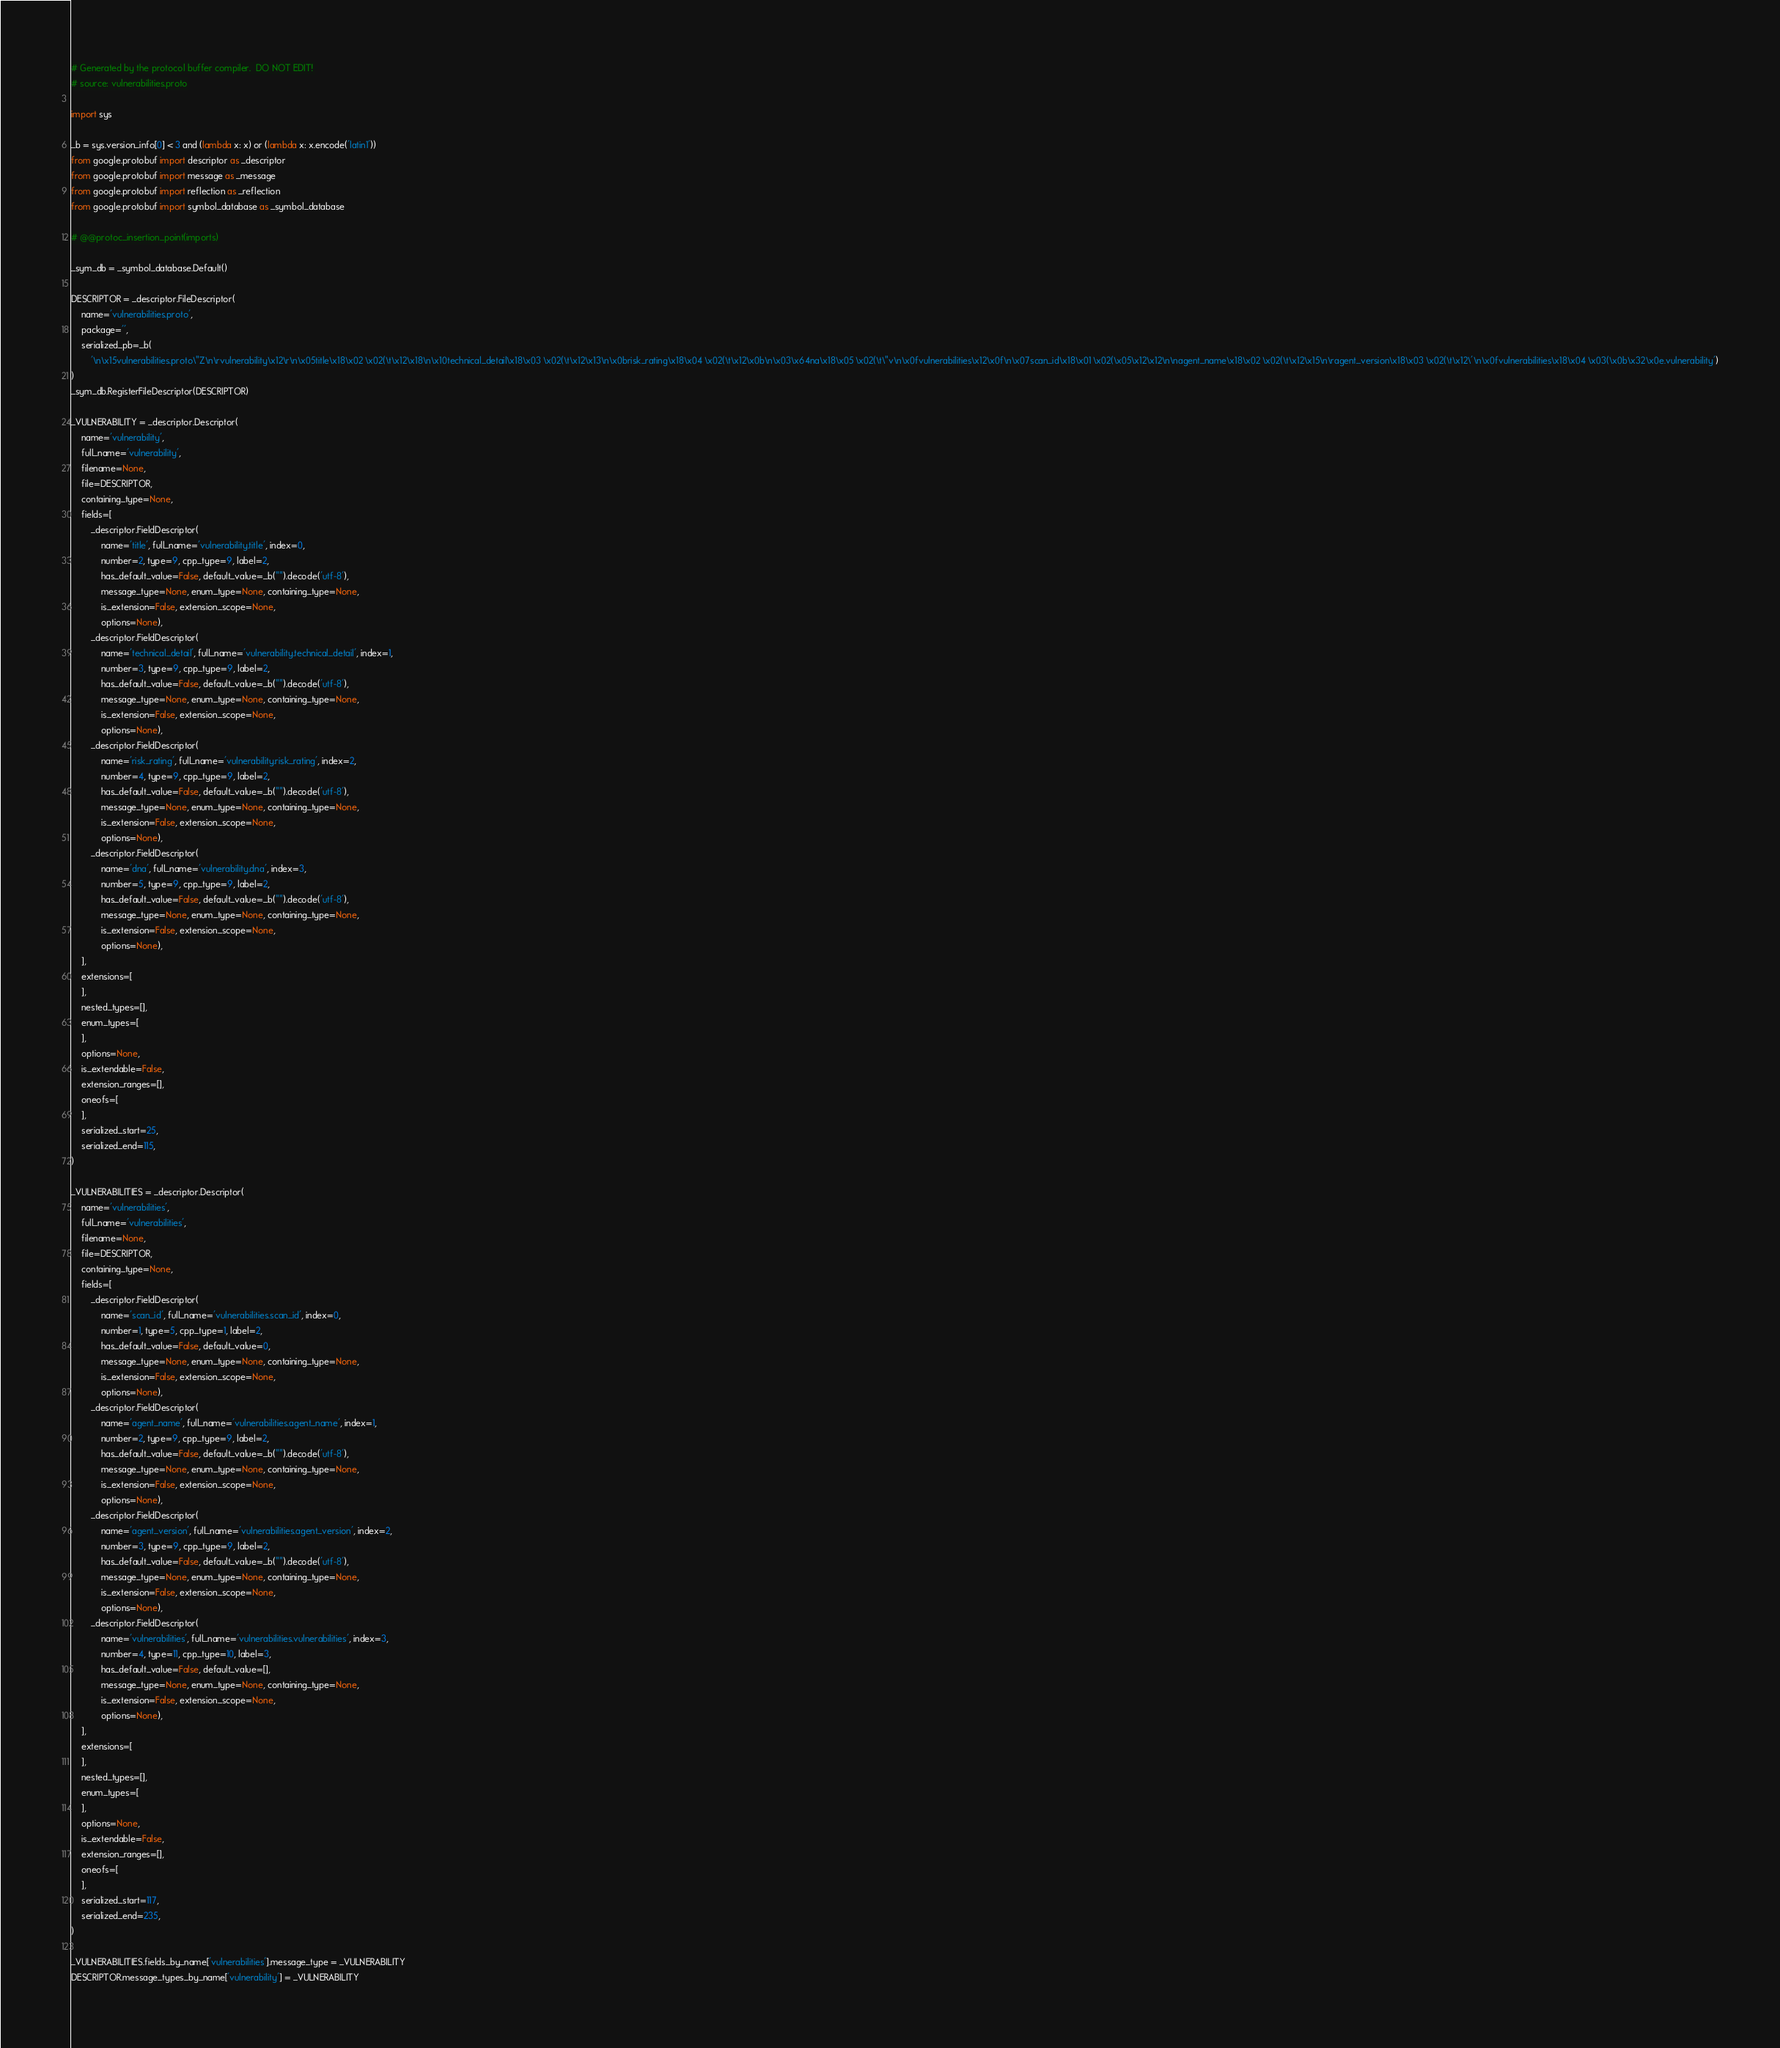<code> <loc_0><loc_0><loc_500><loc_500><_Python_># Generated by the protocol buffer compiler.  DO NOT EDIT!
# source: vulnerabilities.proto

import sys

_b = sys.version_info[0] < 3 and (lambda x: x) or (lambda x: x.encode('latin1'))
from google.protobuf import descriptor as _descriptor
from google.protobuf import message as _message
from google.protobuf import reflection as _reflection
from google.protobuf import symbol_database as _symbol_database

# @@protoc_insertion_point(imports)

_sym_db = _symbol_database.Default()

DESCRIPTOR = _descriptor.FileDescriptor(
    name='vulnerabilities.proto',
    package='',
    serialized_pb=_b(
        '\n\x15vulnerabilities.proto\"Z\n\rvulnerability\x12\r\n\x05title\x18\x02 \x02(\t\x12\x18\n\x10technical_detail\x18\x03 \x02(\t\x12\x13\n\x0brisk_rating\x18\x04 \x02(\t\x12\x0b\n\x03\x64na\x18\x05 \x02(\t\"v\n\x0fvulnerabilities\x12\x0f\n\x07scan_id\x18\x01 \x02(\x05\x12\x12\n\nagent_name\x18\x02 \x02(\t\x12\x15\n\ragent_version\x18\x03 \x02(\t\x12\'\n\x0fvulnerabilities\x18\x04 \x03(\x0b\x32\x0e.vulnerability')
)
_sym_db.RegisterFileDescriptor(DESCRIPTOR)

_VULNERABILITY = _descriptor.Descriptor(
    name='vulnerability',
    full_name='vulnerability',
    filename=None,
    file=DESCRIPTOR,
    containing_type=None,
    fields=[
        _descriptor.FieldDescriptor(
            name='title', full_name='vulnerability.title', index=0,
            number=2, type=9, cpp_type=9, label=2,
            has_default_value=False, default_value=_b("").decode('utf-8'),
            message_type=None, enum_type=None, containing_type=None,
            is_extension=False, extension_scope=None,
            options=None),
        _descriptor.FieldDescriptor(
            name='technical_detail', full_name='vulnerability.technical_detail', index=1,
            number=3, type=9, cpp_type=9, label=2,
            has_default_value=False, default_value=_b("").decode('utf-8'),
            message_type=None, enum_type=None, containing_type=None,
            is_extension=False, extension_scope=None,
            options=None),
        _descriptor.FieldDescriptor(
            name='risk_rating', full_name='vulnerability.risk_rating', index=2,
            number=4, type=9, cpp_type=9, label=2,
            has_default_value=False, default_value=_b("").decode('utf-8'),
            message_type=None, enum_type=None, containing_type=None,
            is_extension=False, extension_scope=None,
            options=None),
        _descriptor.FieldDescriptor(
            name='dna', full_name='vulnerability.dna', index=3,
            number=5, type=9, cpp_type=9, label=2,
            has_default_value=False, default_value=_b("").decode('utf-8'),
            message_type=None, enum_type=None, containing_type=None,
            is_extension=False, extension_scope=None,
            options=None),
    ],
    extensions=[
    ],
    nested_types=[],
    enum_types=[
    ],
    options=None,
    is_extendable=False,
    extension_ranges=[],
    oneofs=[
    ],
    serialized_start=25,
    serialized_end=115,
)

_VULNERABILITIES = _descriptor.Descriptor(
    name='vulnerabilities',
    full_name='vulnerabilities',
    filename=None,
    file=DESCRIPTOR,
    containing_type=None,
    fields=[
        _descriptor.FieldDescriptor(
            name='scan_id', full_name='vulnerabilities.scan_id', index=0,
            number=1, type=5, cpp_type=1, label=2,
            has_default_value=False, default_value=0,
            message_type=None, enum_type=None, containing_type=None,
            is_extension=False, extension_scope=None,
            options=None),
        _descriptor.FieldDescriptor(
            name='agent_name', full_name='vulnerabilities.agent_name', index=1,
            number=2, type=9, cpp_type=9, label=2,
            has_default_value=False, default_value=_b("").decode('utf-8'),
            message_type=None, enum_type=None, containing_type=None,
            is_extension=False, extension_scope=None,
            options=None),
        _descriptor.FieldDescriptor(
            name='agent_version', full_name='vulnerabilities.agent_version', index=2,
            number=3, type=9, cpp_type=9, label=2,
            has_default_value=False, default_value=_b("").decode('utf-8'),
            message_type=None, enum_type=None, containing_type=None,
            is_extension=False, extension_scope=None,
            options=None),
        _descriptor.FieldDescriptor(
            name='vulnerabilities', full_name='vulnerabilities.vulnerabilities', index=3,
            number=4, type=11, cpp_type=10, label=3,
            has_default_value=False, default_value=[],
            message_type=None, enum_type=None, containing_type=None,
            is_extension=False, extension_scope=None,
            options=None),
    ],
    extensions=[
    ],
    nested_types=[],
    enum_types=[
    ],
    options=None,
    is_extendable=False,
    extension_ranges=[],
    oneofs=[
    ],
    serialized_start=117,
    serialized_end=235,
)

_VULNERABILITIES.fields_by_name['vulnerabilities'].message_type = _VULNERABILITY
DESCRIPTOR.message_types_by_name['vulnerability'] = _VULNERABILITY</code> 